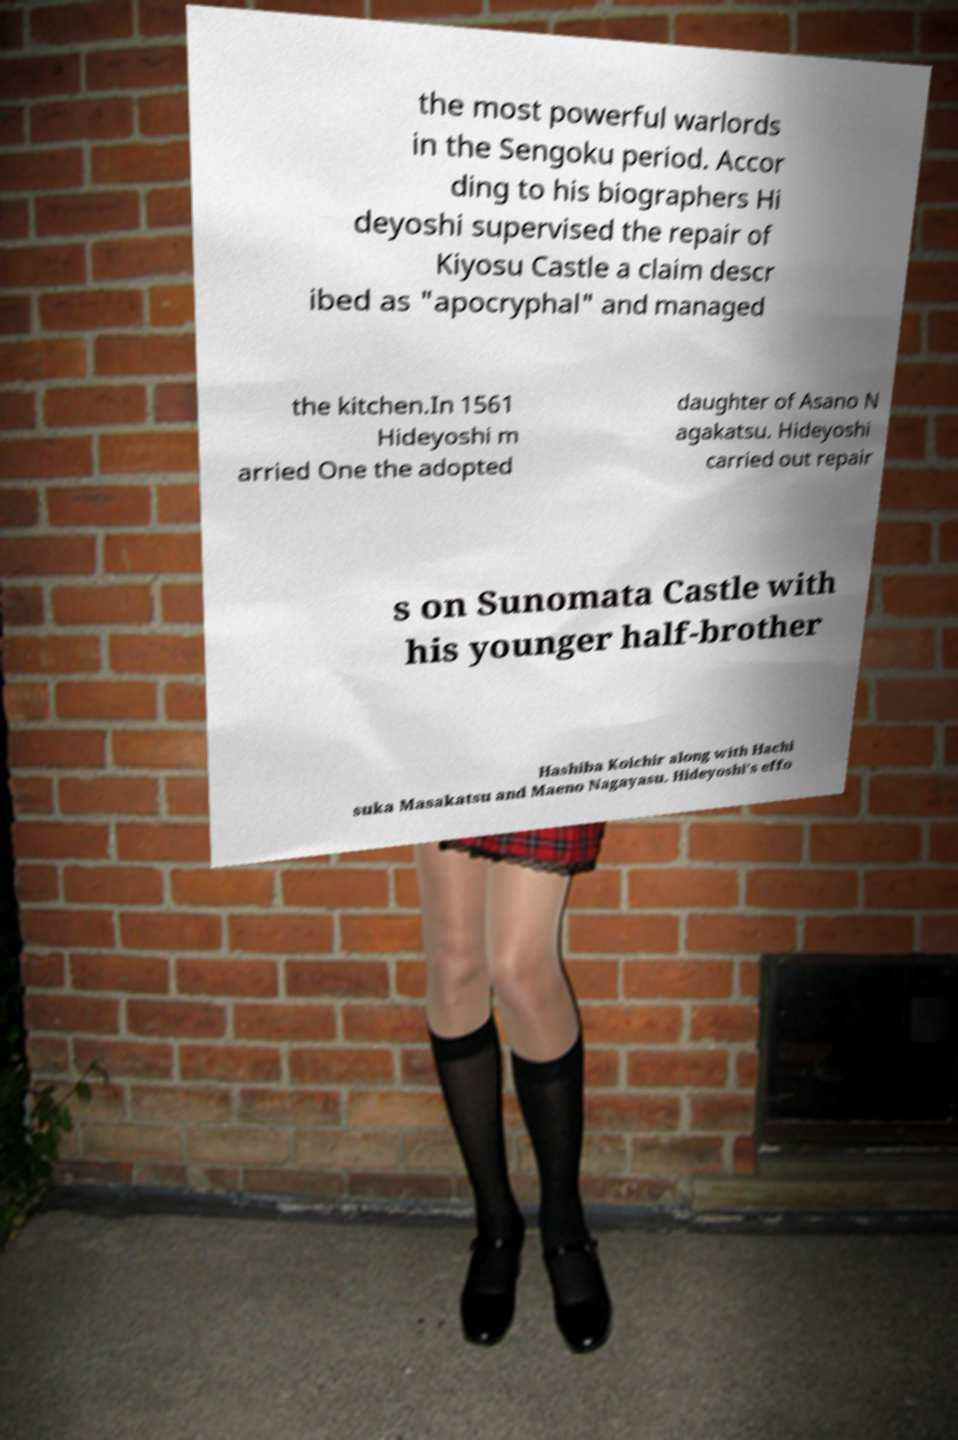Can you accurately transcribe the text from the provided image for me? the most powerful warlords in the Sengoku period. Accor ding to his biographers Hi deyoshi supervised the repair of Kiyosu Castle a claim descr ibed as "apocryphal" and managed the kitchen.In 1561 Hideyoshi m arried One the adopted daughter of Asano N agakatsu. Hideyoshi carried out repair s on Sunomata Castle with his younger half-brother Hashiba Koichir along with Hachi suka Masakatsu and Maeno Nagayasu. Hideyoshi's effo 